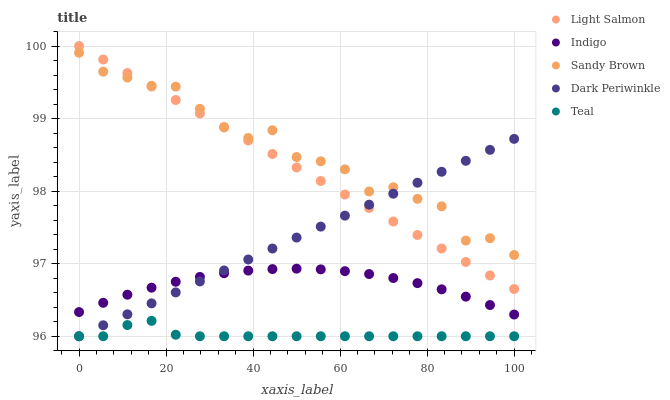Does Teal have the minimum area under the curve?
Answer yes or no. Yes. Does Sandy Brown have the maximum area under the curve?
Answer yes or no. Yes. Does Light Salmon have the minimum area under the curve?
Answer yes or no. No. Does Light Salmon have the maximum area under the curve?
Answer yes or no. No. Is Dark Periwinkle the smoothest?
Answer yes or no. Yes. Is Sandy Brown the roughest?
Answer yes or no. Yes. Is Light Salmon the smoothest?
Answer yes or no. No. Is Light Salmon the roughest?
Answer yes or no. No. Does Dark Periwinkle have the lowest value?
Answer yes or no. Yes. Does Light Salmon have the lowest value?
Answer yes or no. No. Does Light Salmon have the highest value?
Answer yes or no. Yes. Does Indigo have the highest value?
Answer yes or no. No. Is Indigo less than Light Salmon?
Answer yes or no. Yes. Is Sandy Brown greater than Indigo?
Answer yes or no. Yes. Does Dark Periwinkle intersect Sandy Brown?
Answer yes or no. Yes. Is Dark Periwinkle less than Sandy Brown?
Answer yes or no. No. Is Dark Periwinkle greater than Sandy Brown?
Answer yes or no. No. Does Indigo intersect Light Salmon?
Answer yes or no. No. 